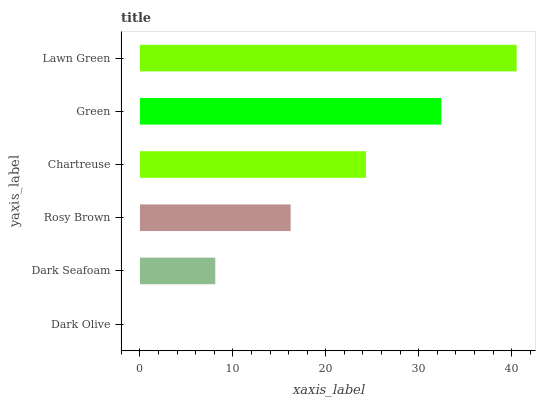Is Dark Olive the minimum?
Answer yes or no. Yes. Is Lawn Green the maximum?
Answer yes or no. Yes. Is Dark Seafoam the minimum?
Answer yes or no. No. Is Dark Seafoam the maximum?
Answer yes or no. No. Is Dark Seafoam greater than Dark Olive?
Answer yes or no. Yes. Is Dark Olive less than Dark Seafoam?
Answer yes or no. Yes. Is Dark Olive greater than Dark Seafoam?
Answer yes or no. No. Is Dark Seafoam less than Dark Olive?
Answer yes or no. No. Is Chartreuse the high median?
Answer yes or no. Yes. Is Rosy Brown the low median?
Answer yes or no. Yes. Is Dark Seafoam the high median?
Answer yes or no. No. Is Lawn Green the low median?
Answer yes or no. No. 